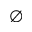Convert formula to latex. <formula><loc_0><loc_0><loc_500><loc_500>\emptyset</formula> 